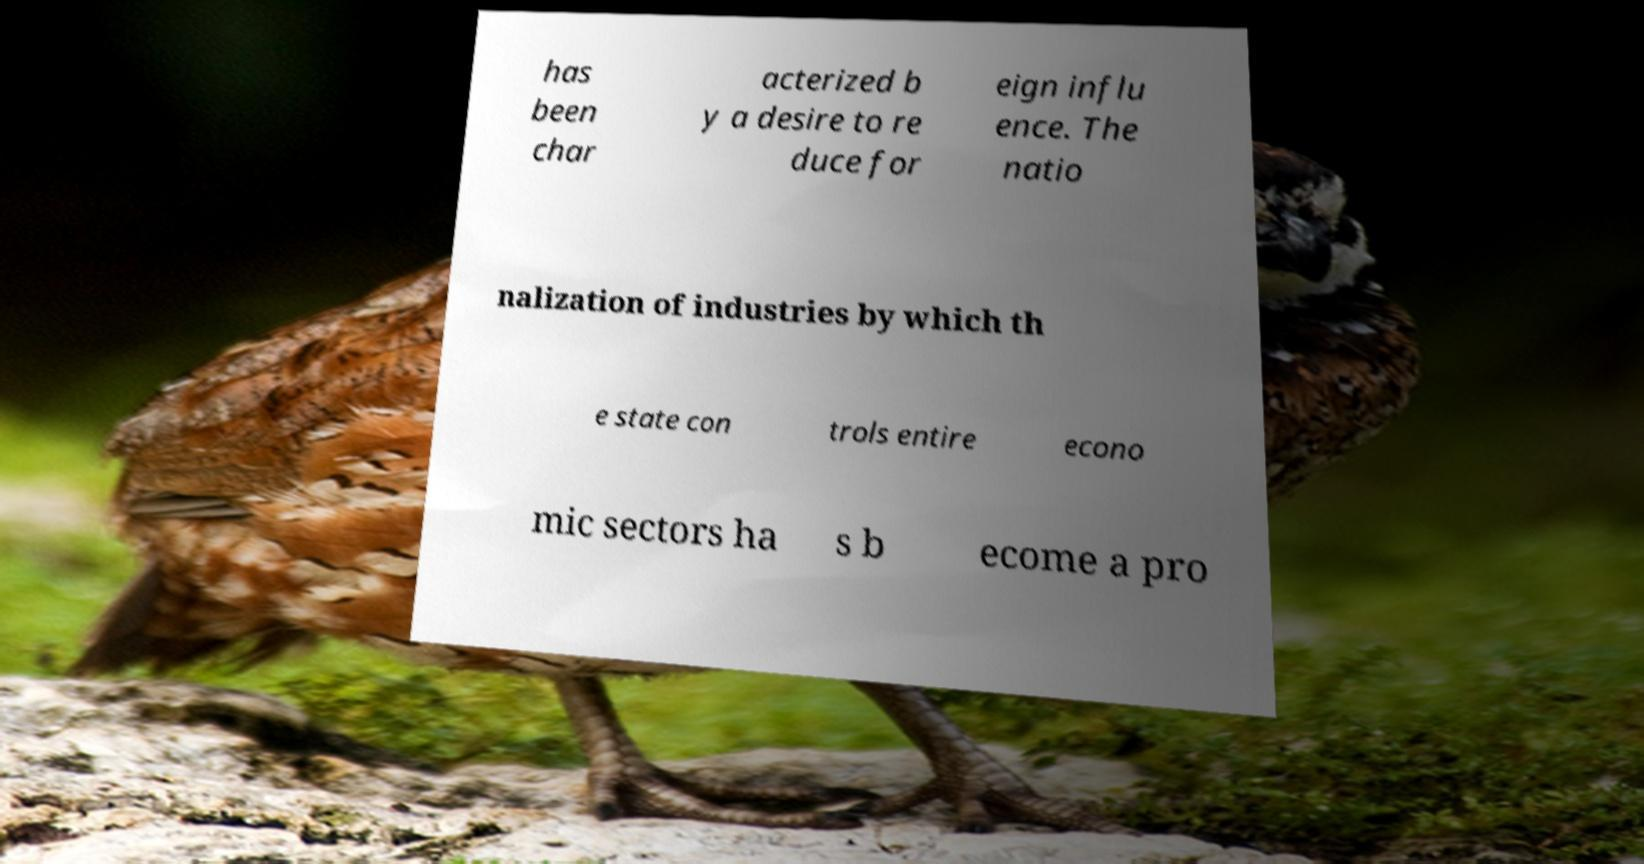Could you extract and type out the text from this image? has been char acterized b y a desire to re duce for eign influ ence. The natio nalization of industries by which th e state con trols entire econo mic sectors ha s b ecome a pro 